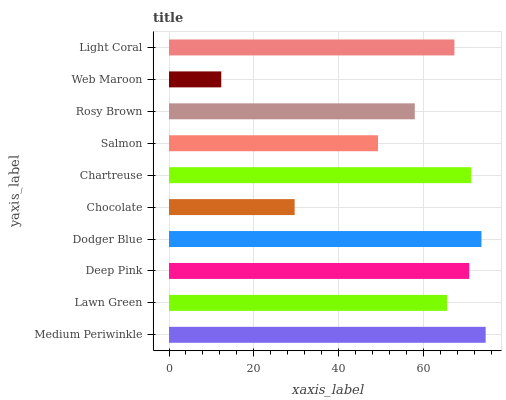Is Web Maroon the minimum?
Answer yes or no. Yes. Is Medium Periwinkle the maximum?
Answer yes or no. Yes. Is Lawn Green the minimum?
Answer yes or no. No. Is Lawn Green the maximum?
Answer yes or no. No. Is Medium Periwinkle greater than Lawn Green?
Answer yes or no. Yes. Is Lawn Green less than Medium Periwinkle?
Answer yes or no. Yes. Is Lawn Green greater than Medium Periwinkle?
Answer yes or no. No. Is Medium Periwinkle less than Lawn Green?
Answer yes or no. No. Is Light Coral the high median?
Answer yes or no. Yes. Is Lawn Green the low median?
Answer yes or no. Yes. Is Lawn Green the high median?
Answer yes or no. No. Is Rosy Brown the low median?
Answer yes or no. No. 